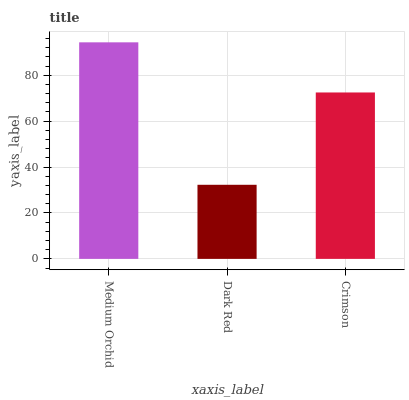Is Dark Red the minimum?
Answer yes or no. Yes. Is Medium Orchid the maximum?
Answer yes or no. Yes. Is Crimson the minimum?
Answer yes or no. No. Is Crimson the maximum?
Answer yes or no. No. Is Crimson greater than Dark Red?
Answer yes or no. Yes. Is Dark Red less than Crimson?
Answer yes or no. Yes. Is Dark Red greater than Crimson?
Answer yes or no. No. Is Crimson less than Dark Red?
Answer yes or no. No. Is Crimson the high median?
Answer yes or no. Yes. Is Crimson the low median?
Answer yes or no. Yes. Is Medium Orchid the high median?
Answer yes or no. No. Is Medium Orchid the low median?
Answer yes or no. No. 